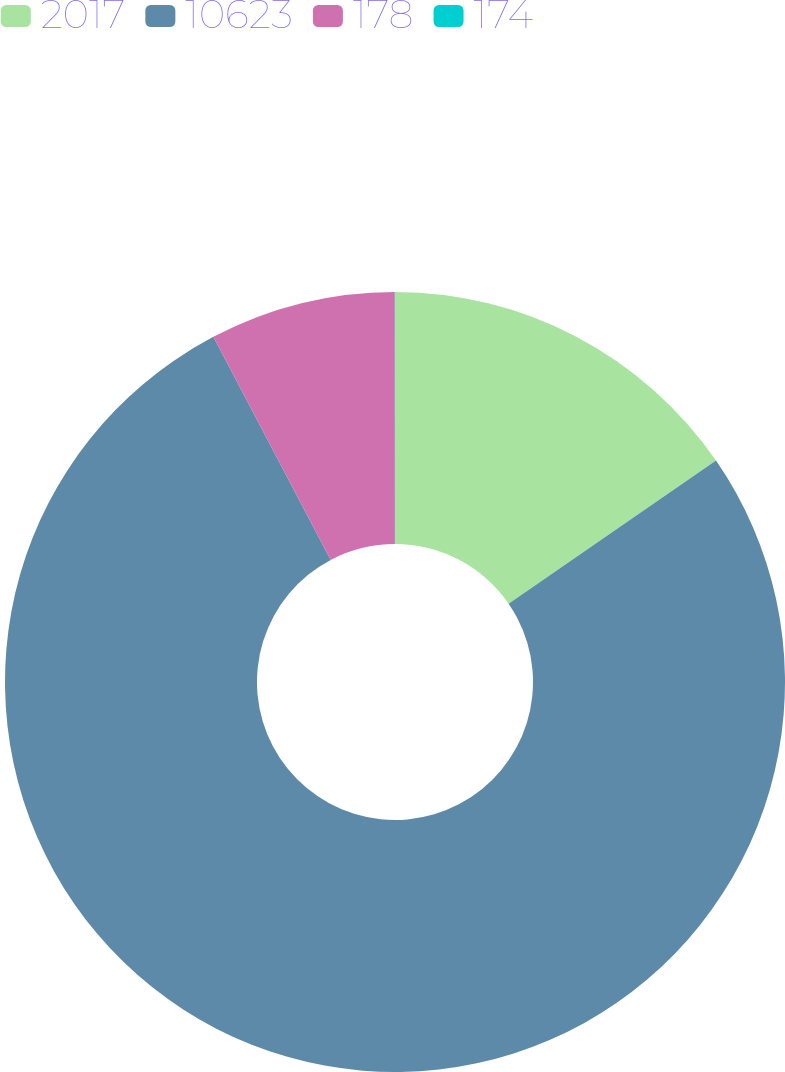Convert chart. <chart><loc_0><loc_0><loc_500><loc_500><pie_chart><fcel>2017<fcel>10623<fcel>178<fcel>174<nl><fcel>15.39%<fcel>76.91%<fcel>7.7%<fcel>0.01%<nl></chart> 